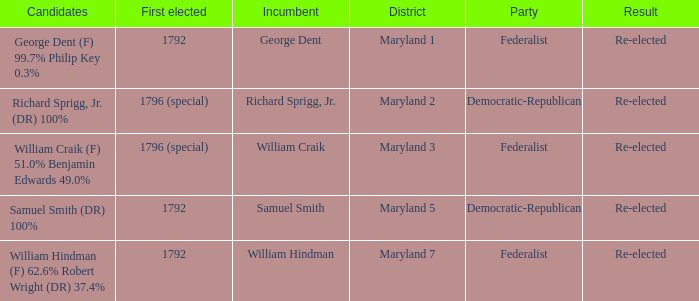Who is the candidates for district maryland 1? George Dent (F) 99.7% Philip Key 0.3%. 